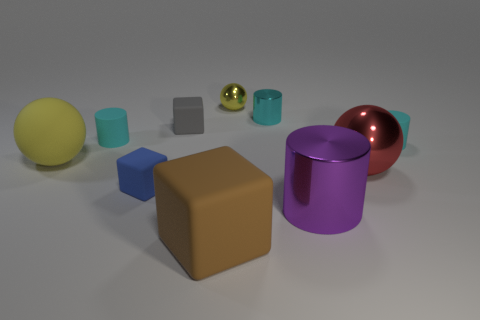How do the various objects in the image differ in texture and color? The objects in the image display a variety of textures: some appear to have a matte surface, while others are reflective, potentially indicating metallic properties. Color-wise, there's a range present, from cyan to red, yellow, and earth tones, each creating a visual contrast with one another. 